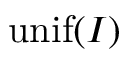<formula> <loc_0><loc_0><loc_500><loc_500>{ u n i f } ( I )</formula> 